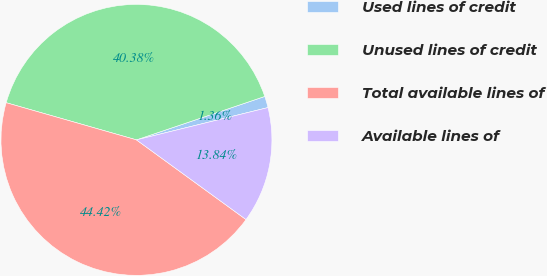Convert chart to OTSL. <chart><loc_0><loc_0><loc_500><loc_500><pie_chart><fcel>Used lines of credit<fcel>Unused lines of credit<fcel>Total available lines of<fcel>Available lines of<nl><fcel>1.36%<fcel>40.38%<fcel>44.42%<fcel>13.84%<nl></chart> 